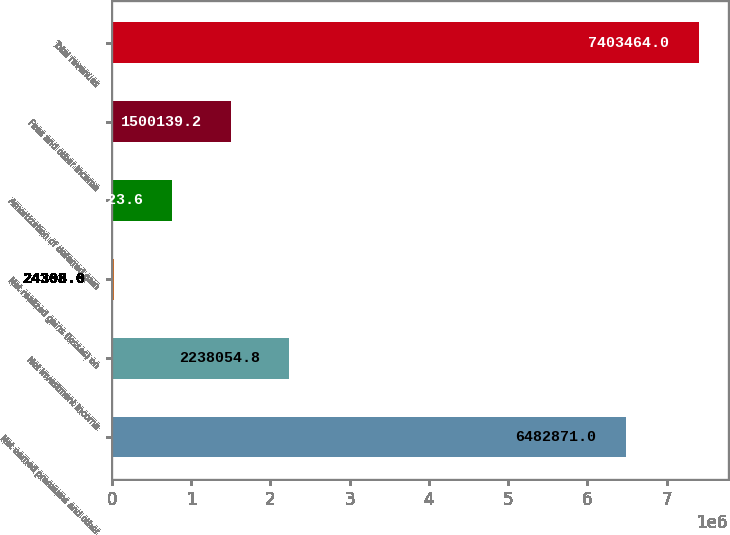Convert chart to OTSL. <chart><loc_0><loc_0><loc_500><loc_500><bar_chart><fcel>Net earned premiums and other<fcel>Net investment income<fcel>Net realized gains (losses) on<fcel>Amortization of deferred gain<fcel>Fees and other income<fcel>Total revenues<nl><fcel>6.48287e+06<fcel>2.23805e+06<fcel>24308<fcel>762224<fcel>1.50014e+06<fcel>7.40346e+06<nl></chart> 